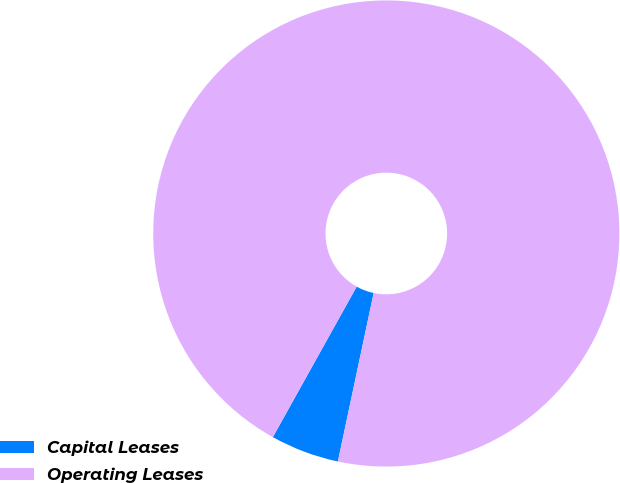Convert chart. <chart><loc_0><loc_0><loc_500><loc_500><pie_chart><fcel>Capital Leases<fcel>Operating Leases<nl><fcel>4.76%<fcel>95.24%<nl></chart> 